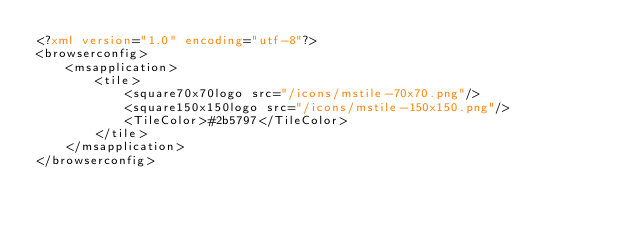<code> <loc_0><loc_0><loc_500><loc_500><_XML_><?xml version="1.0" encoding="utf-8"?>
<browserconfig>
    <msapplication>
        <tile>
            <square70x70logo src="/icons/mstile-70x70.png"/>
            <square150x150logo src="/icons/mstile-150x150.png"/>
            <TileColor>#2b5797</TileColor>
        </tile>
    </msapplication>
</browserconfig>
</code> 